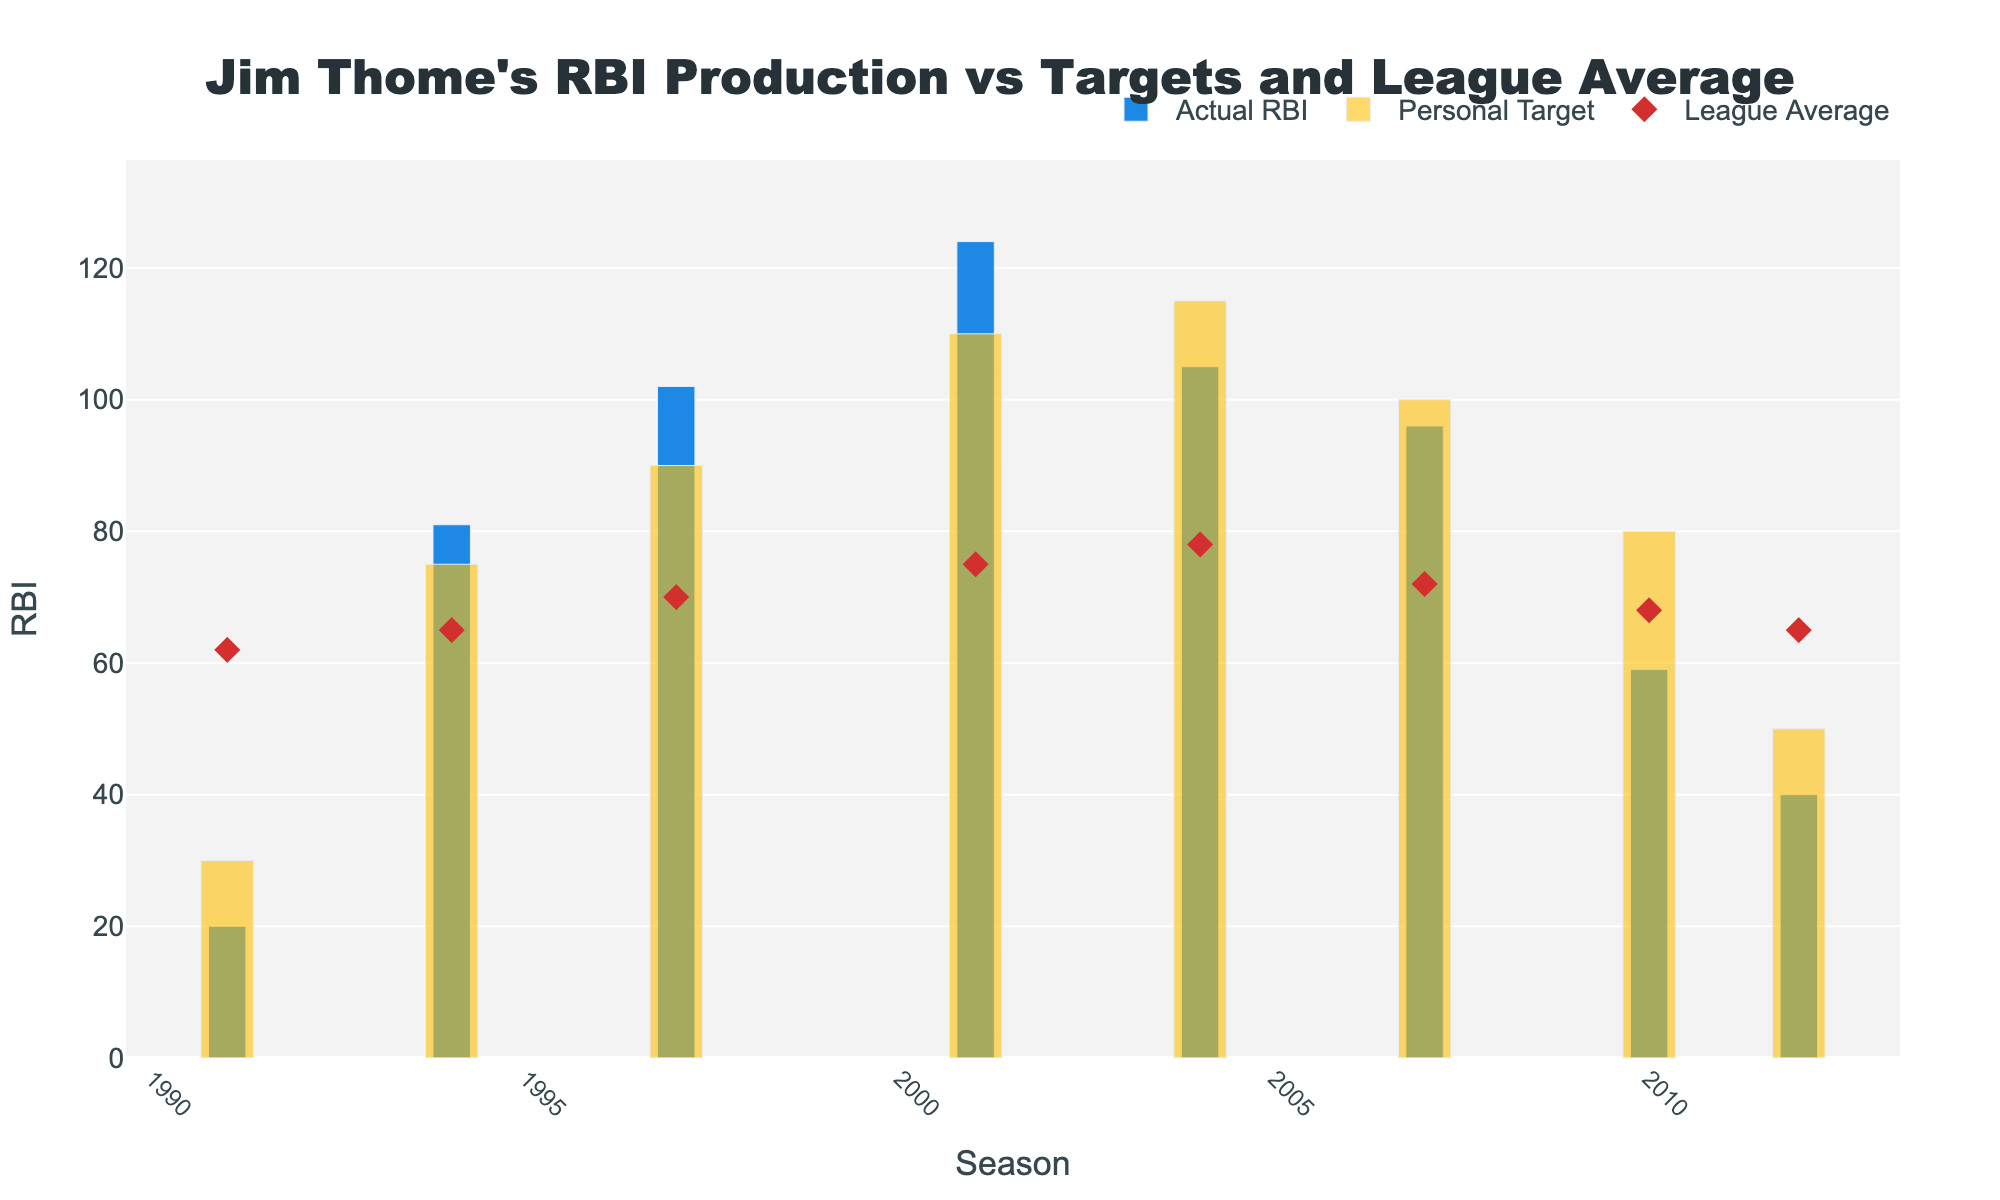What is the title of the figure? The title is displayed at the top center of the figure. In this case, it reads "Jim Thome's RBI Production vs Targets and League Average".
Answer: Jim Thome's RBI Production vs Targets and League Average How many seasons are there in the data? By counting the number of distinct seasons marked on the x-axis, we find there are eight seasons in the chart.
Answer: Eight What was Jim Thome's Actual RBI in the 2001 season? Look at the bar representing the actual RBI for the 2001 season on the chart and read its height. The blue bar in 2001 shows the Actual RBI as 124.
Answer: 124 In which season did Jim Thome exceed his Personal Targets by the largest margin? To find the largest margin, calculate the difference between Actual RBI and Personal Targets for each season and identify the maximum. In 2001, the difference is 124 - 110 = 14, which is the largest.
Answer: 2001 How many seasons did Jim Thome underperform compared to his Personal Targets? Compare the height of the blue bars (Actual RBI) with the yellow bars (Personal Targets). He underperformed in 4 seasons: 1991, 2004, 2007, and 2010.
Answer: Four Which season had the lowest Actual RBI for Jim Thome? Scan through the blue bars representing Actual RBI for each season and identify which bar is the shortest. The shortest blue bar is in 1991, where his Actual RBI was 20.
Answer: 1991 What was the League Average RBI in 1997? Locate the diamond marker for the 1997 season and read its position on the y-axis. The red diamond indicates a League Average of 70 RBI.
Answer: 70 In how many seasons did Jim Thome's Actual RBI surpass the League Average? Compare the height of the blue bars with the red diamond markers for each season. He surpassed the League Average in 5 seasons: 1994, 1997, 2001, 2004, and 2007.
Answer: Five What’s the average Actual RBI for the seasons shown? Sum the Actual RBI values and divide by the number of seasons. The Actual RBI values are 20, 81, 102, 124, 105, 96, 59, and 40. Their sum is 627. Dividing by 8 seasons gives an average of 627 / 8 = 78.375.
Answer: 78.375 What is the color of the bars representing Jim Thome's Personal Targets? Look at the bars representing Personal Targets, which appear in yellow with partial transparency.
Answer: Yellow 